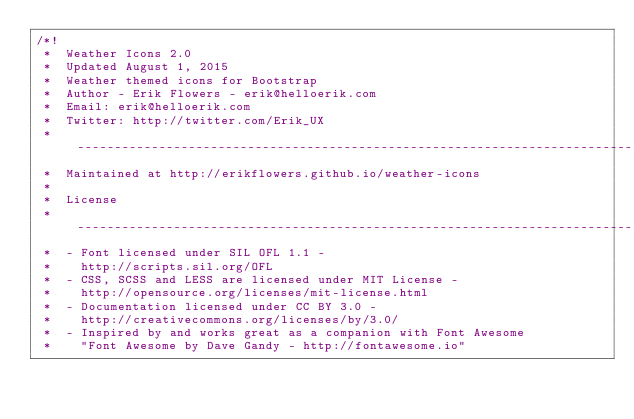<code> <loc_0><loc_0><loc_500><loc_500><_CSS_>/*!
 *  Weather Icons 2.0
 *  Updated August 1, 2015
 *  Weather themed icons for Bootstrap
 *  Author - Erik Flowers - erik@helloerik.com
 *  Email: erik@helloerik.com
 *  Twitter: http://twitter.com/Erik_UX
 *  ------------------------------------------------------------------------------
 *  Maintained at http://erikflowers.github.io/weather-icons
 *
 *  License
 *  ------------------------------------------------------------------------------
 *  - Font licensed under SIL OFL 1.1 -
 *    http://scripts.sil.org/OFL
 *  - CSS, SCSS and LESS are licensed under MIT License -
 *    http://opensource.org/licenses/mit-license.html
 *  - Documentation licensed under CC BY 3.0 -
 *    http://creativecommons.org/licenses/by/3.0/
 *  - Inspired by and works great as a companion with Font Awesome
 *    "Font Awesome by Dave Gandy - http://fontawesome.io"</code> 